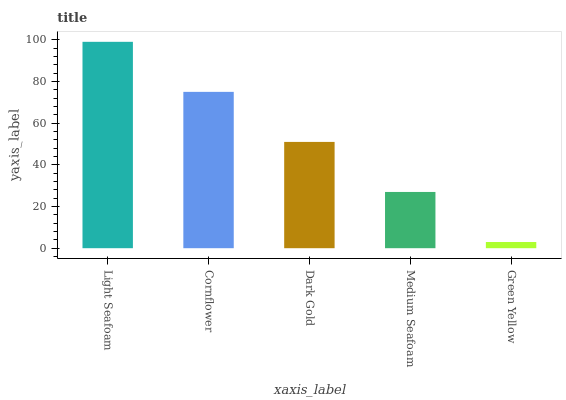Is Green Yellow the minimum?
Answer yes or no. Yes. Is Light Seafoam the maximum?
Answer yes or no. Yes. Is Cornflower the minimum?
Answer yes or no. No. Is Cornflower the maximum?
Answer yes or no. No. Is Light Seafoam greater than Cornflower?
Answer yes or no. Yes. Is Cornflower less than Light Seafoam?
Answer yes or no. Yes. Is Cornflower greater than Light Seafoam?
Answer yes or no. No. Is Light Seafoam less than Cornflower?
Answer yes or no. No. Is Dark Gold the high median?
Answer yes or no. Yes. Is Dark Gold the low median?
Answer yes or no. Yes. Is Medium Seafoam the high median?
Answer yes or no. No. Is Cornflower the low median?
Answer yes or no. No. 